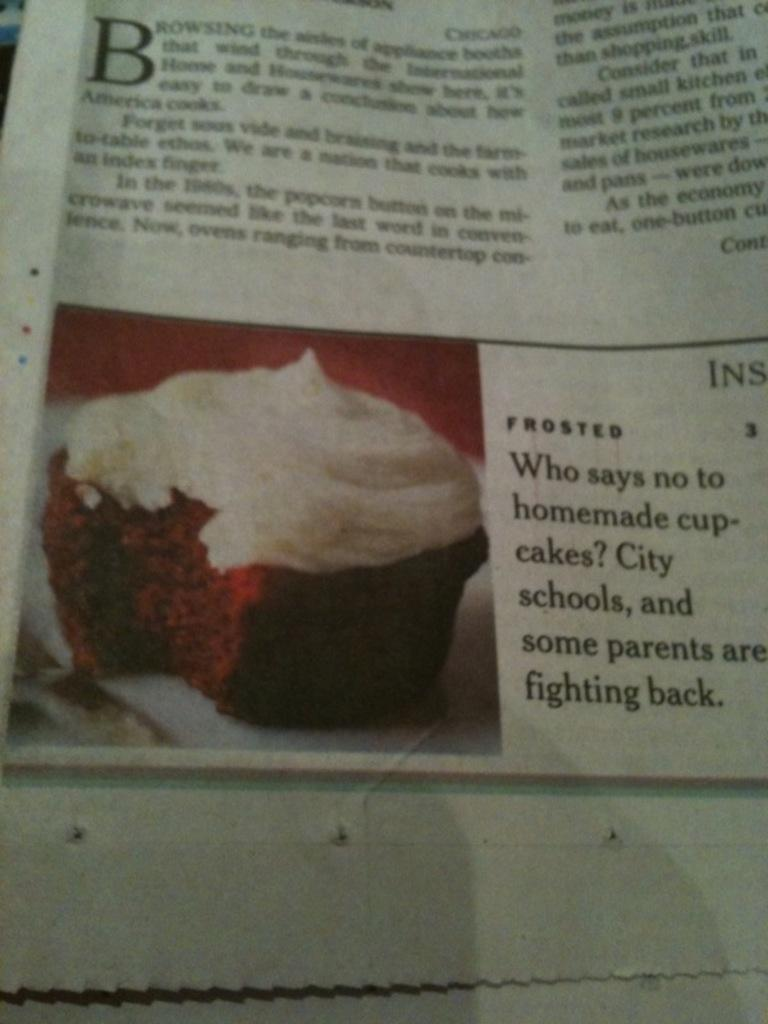<image>
Give a short and clear explanation of the subsequent image. A newspaper article entitled "Who says no to homemade cup-cakes? City schools, and some parents are fighting back." 